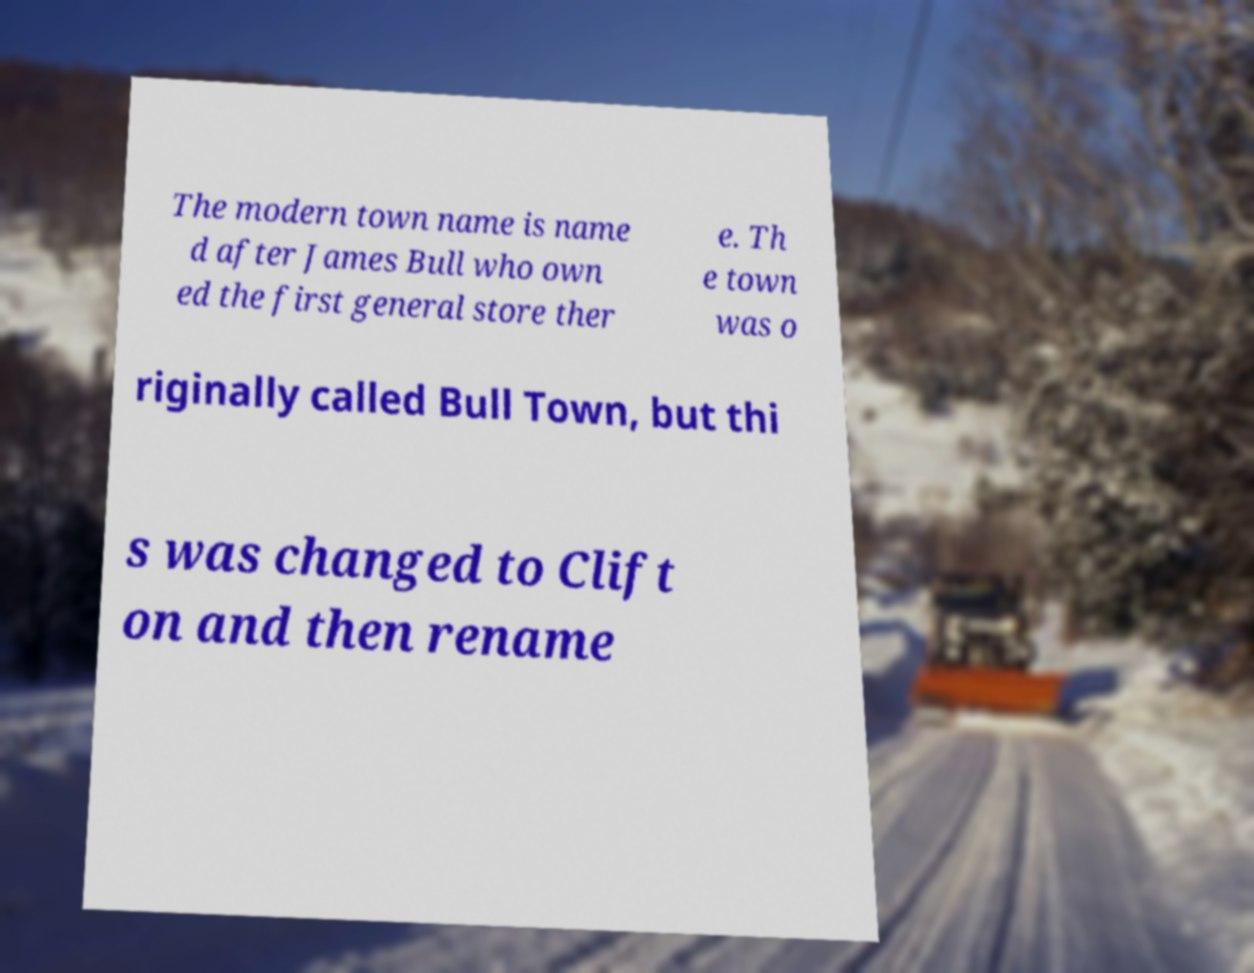Please identify and transcribe the text found in this image. The modern town name is name d after James Bull who own ed the first general store ther e. Th e town was o riginally called Bull Town, but thi s was changed to Clift on and then rename 